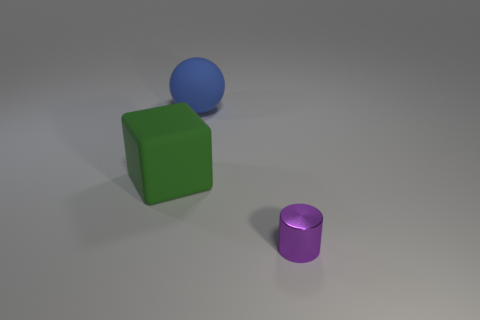The big rubber thing to the right of the large rubber object that is in front of the rubber object that is behind the green rubber cube is what color?
Your response must be concise. Blue. Are there more tiny objects that are in front of the small metal thing than large blue matte things in front of the big rubber ball?
Give a very brief answer. No. What number of other things are the same size as the green rubber object?
Ensure brevity in your answer.  1. What is the material of the large thing that is right of the matte thing to the left of the blue matte thing?
Your response must be concise. Rubber. There is a blue rubber ball; are there any objects on the right side of it?
Give a very brief answer. Yes. Is the number of big objects in front of the blue thing greater than the number of big metallic cubes?
Provide a succinct answer. Yes. Are there any tiny objects of the same color as the small metal cylinder?
Provide a short and direct response. No. What color is the other rubber object that is the same size as the blue object?
Offer a terse response. Green. There is a matte object on the left side of the blue matte object; is there a tiny purple cylinder that is in front of it?
Offer a very short reply. Yes. What is the material of the big thing that is in front of the big blue rubber thing?
Keep it short and to the point. Rubber. 